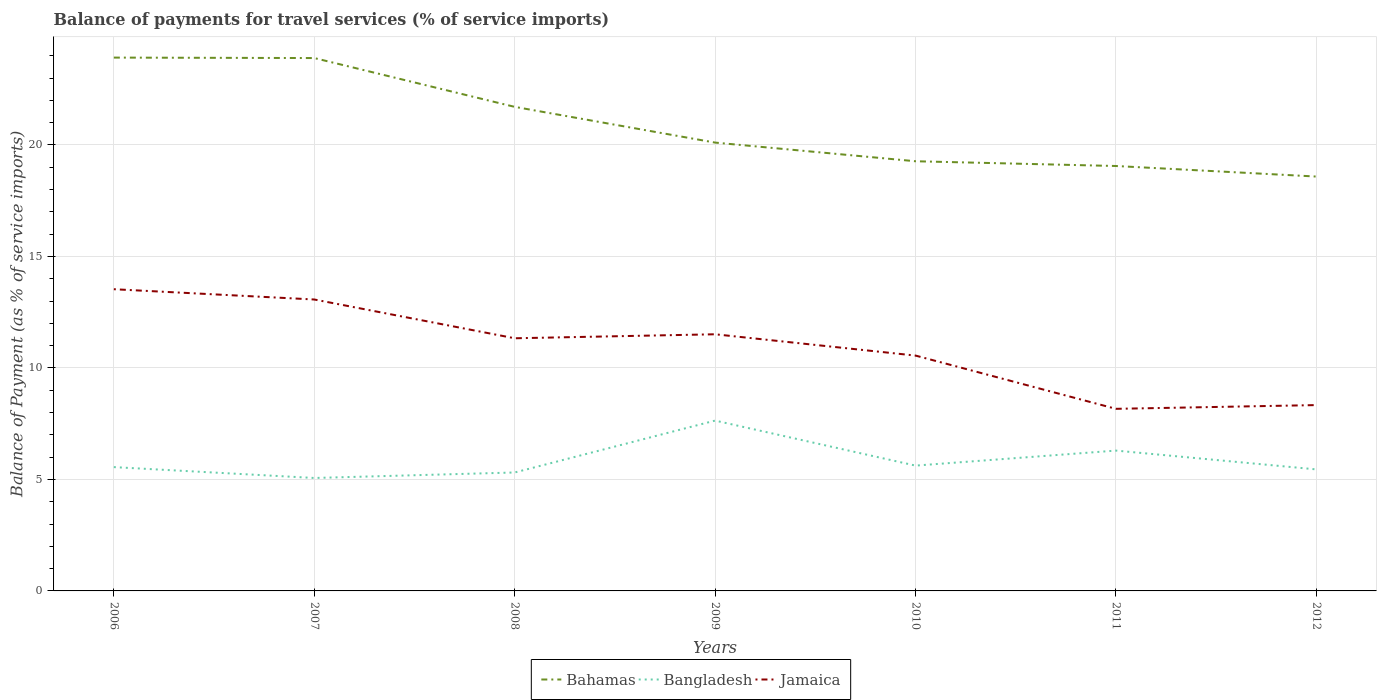Does the line corresponding to Bahamas intersect with the line corresponding to Jamaica?
Your answer should be very brief. No. Is the number of lines equal to the number of legend labels?
Provide a short and direct response. Yes. Across all years, what is the maximum balance of payments for travel services in Bahamas?
Provide a succinct answer. 18.58. In which year was the balance of payments for travel services in Jamaica maximum?
Offer a very short reply. 2011. What is the total balance of payments for travel services in Jamaica in the graph?
Your response must be concise. 0.78. What is the difference between the highest and the second highest balance of payments for travel services in Jamaica?
Make the answer very short. 5.36. What is the difference between the highest and the lowest balance of payments for travel services in Bangladesh?
Your response must be concise. 2. Is the balance of payments for travel services in Bangladesh strictly greater than the balance of payments for travel services in Bahamas over the years?
Your answer should be compact. Yes. What is the difference between two consecutive major ticks on the Y-axis?
Offer a very short reply. 5. Are the values on the major ticks of Y-axis written in scientific E-notation?
Make the answer very short. No. Where does the legend appear in the graph?
Your answer should be compact. Bottom center. How are the legend labels stacked?
Provide a short and direct response. Horizontal. What is the title of the graph?
Give a very brief answer. Balance of payments for travel services (% of service imports). What is the label or title of the Y-axis?
Keep it short and to the point. Balance of Payment (as % of service imports). What is the Balance of Payment (as % of service imports) in Bahamas in 2006?
Ensure brevity in your answer.  23.92. What is the Balance of Payment (as % of service imports) of Bangladesh in 2006?
Provide a short and direct response. 5.55. What is the Balance of Payment (as % of service imports) of Jamaica in 2006?
Give a very brief answer. 13.53. What is the Balance of Payment (as % of service imports) in Bahamas in 2007?
Make the answer very short. 23.89. What is the Balance of Payment (as % of service imports) in Bangladesh in 2007?
Keep it short and to the point. 5.06. What is the Balance of Payment (as % of service imports) in Jamaica in 2007?
Your answer should be compact. 13.07. What is the Balance of Payment (as % of service imports) of Bahamas in 2008?
Ensure brevity in your answer.  21.71. What is the Balance of Payment (as % of service imports) of Bangladesh in 2008?
Your response must be concise. 5.31. What is the Balance of Payment (as % of service imports) of Jamaica in 2008?
Make the answer very short. 11.33. What is the Balance of Payment (as % of service imports) in Bahamas in 2009?
Ensure brevity in your answer.  20.1. What is the Balance of Payment (as % of service imports) in Bangladesh in 2009?
Provide a succinct answer. 7.64. What is the Balance of Payment (as % of service imports) of Jamaica in 2009?
Keep it short and to the point. 11.51. What is the Balance of Payment (as % of service imports) of Bahamas in 2010?
Offer a very short reply. 19.27. What is the Balance of Payment (as % of service imports) of Bangladesh in 2010?
Provide a succinct answer. 5.62. What is the Balance of Payment (as % of service imports) in Jamaica in 2010?
Make the answer very short. 10.55. What is the Balance of Payment (as % of service imports) of Bahamas in 2011?
Give a very brief answer. 19.05. What is the Balance of Payment (as % of service imports) in Bangladesh in 2011?
Your answer should be compact. 6.29. What is the Balance of Payment (as % of service imports) of Jamaica in 2011?
Provide a succinct answer. 8.17. What is the Balance of Payment (as % of service imports) in Bahamas in 2012?
Provide a succinct answer. 18.58. What is the Balance of Payment (as % of service imports) of Bangladesh in 2012?
Provide a succinct answer. 5.45. What is the Balance of Payment (as % of service imports) of Jamaica in 2012?
Offer a very short reply. 8.33. Across all years, what is the maximum Balance of Payment (as % of service imports) in Bahamas?
Ensure brevity in your answer.  23.92. Across all years, what is the maximum Balance of Payment (as % of service imports) of Bangladesh?
Give a very brief answer. 7.64. Across all years, what is the maximum Balance of Payment (as % of service imports) in Jamaica?
Ensure brevity in your answer.  13.53. Across all years, what is the minimum Balance of Payment (as % of service imports) of Bahamas?
Your answer should be very brief. 18.58. Across all years, what is the minimum Balance of Payment (as % of service imports) of Bangladesh?
Keep it short and to the point. 5.06. Across all years, what is the minimum Balance of Payment (as % of service imports) in Jamaica?
Ensure brevity in your answer.  8.17. What is the total Balance of Payment (as % of service imports) of Bahamas in the graph?
Your answer should be compact. 146.52. What is the total Balance of Payment (as % of service imports) of Bangladesh in the graph?
Provide a succinct answer. 40.93. What is the total Balance of Payment (as % of service imports) in Jamaica in the graph?
Offer a terse response. 76.49. What is the difference between the Balance of Payment (as % of service imports) of Bahamas in 2006 and that in 2007?
Offer a very short reply. 0.02. What is the difference between the Balance of Payment (as % of service imports) in Bangladesh in 2006 and that in 2007?
Keep it short and to the point. 0.49. What is the difference between the Balance of Payment (as % of service imports) of Jamaica in 2006 and that in 2007?
Your answer should be compact. 0.46. What is the difference between the Balance of Payment (as % of service imports) of Bahamas in 2006 and that in 2008?
Your response must be concise. 2.21. What is the difference between the Balance of Payment (as % of service imports) in Bangladesh in 2006 and that in 2008?
Your response must be concise. 0.24. What is the difference between the Balance of Payment (as % of service imports) in Jamaica in 2006 and that in 2008?
Make the answer very short. 2.2. What is the difference between the Balance of Payment (as % of service imports) in Bahamas in 2006 and that in 2009?
Your answer should be very brief. 3.81. What is the difference between the Balance of Payment (as % of service imports) of Bangladesh in 2006 and that in 2009?
Your response must be concise. -2.09. What is the difference between the Balance of Payment (as % of service imports) of Jamaica in 2006 and that in 2009?
Offer a very short reply. 2.02. What is the difference between the Balance of Payment (as % of service imports) in Bahamas in 2006 and that in 2010?
Offer a very short reply. 4.65. What is the difference between the Balance of Payment (as % of service imports) of Bangladesh in 2006 and that in 2010?
Your answer should be compact. -0.07. What is the difference between the Balance of Payment (as % of service imports) of Jamaica in 2006 and that in 2010?
Ensure brevity in your answer.  2.98. What is the difference between the Balance of Payment (as % of service imports) in Bahamas in 2006 and that in 2011?
Provide a succinct answer. 4.86. What is the difference between the Balance of Payment (as % of service imports) of Bangladesh in 2006 and that in 2011?
Provide a succinct answer. -0.74. What is the difference between the Balance of Payment (as % of service imports) in Jamaica in 2006 and that in 2011?
Your response must be concise. 5.36. What is the difference between the Balance of Payment (as % of service imports) in Bahamas in 2006 and that in 2012?
Your answer should be compact. 5.33. What is the difference between the Balance of Payment (as % of service imports) of Bangladesh in 2006 and that in 2012?
Keep it short and to the point. 0.1. What is the difference between the Balance of Payment (as % of service imports) in Jamaica in 2006 and that in 2012?
Offer a very short reply. 5.2. What is the difference between the Balance of Payment (as % of service imports) in Bahamas in 2007 and that in 2008?
Give a very brief answer. 2.19. What is the difference between the Balance of Payment (as % of service imports) in Bangladesh in 2007 and that in 2008?
Give a very brief answer. -0.25. What is the difference between the Balance of Payment (as % of service imports) of Jamaica in 2007 and that in 2008?
Keep it short and to the point. 1.74. What is the difference between the Balance of Payment (as % of service imports) in Bahamas in 2007 and that in 2009?
Offer a terse response. 3.79. What is the difference between the Balance of Payment (as % of service imports) in Bangladesh in 2007 and that in 2009?
Offer a terse response. -2.57. What is the difference between the Balance of Payment (as % of service imports) of Jamaica in 2007 and that in 2009?
Give a very brief answer. 1.56. What is the difference between the Balance of Payment (as % of service imports) of Bahamas in 2007 and that in 2010?
Keep it short and to the point. 4.63. What is the difference between the Balance of Payment (as % of service imports) in Bangladesh in 2007 and that in 2010?
Ensure brevity in your answer.  -0.55. What is the difference between the Balance of Payment (as % of service imports) of Jamaica in 2007 and that in 2010?
Offer a terse response. 2.51. What is the difference between the Balance of Payment (as % of service imports) in Bahamas in 2007 and that in 2011?
Provide a short and direct response. 4.84. What is the difference between the Balance of Payment (as % of service imports) in Bangladesh in 2007 and that in 2011?
Keep it short and to the point. -1.23. What is the difference between the Balance of Payment (as % of service imports) in Jamaica in 2007 and that in 2011?
Make the answer very short. 4.9. What is the difference between the Balance of Payment (as % of service imports) in Bahamas in 2007 and that in 2012?
Ensure brevity in your answer.  5.31. What is the difference between the Balance of Payment (as % of service imports) in Bangladesh in 2007 and that in 2012?
Offer a terse response. -0.38. What is the difference between the Balance of Payment (as % of service imports) in Jamaica in 2007 and that in 2012?
Your answer should be very brief. 4.73. What is the difference between the Balance of Payment (as % of service imports) in Bahamas in 2008 and that in 2009?
Give a very brief answer. 1.6. What is the difference between the Balance of Payment (as % of service imports) of Bangladesh in 2008 and that in 2009?
Make the answer very short. -2.33. What is the difference between the Balance of Payment (as % of service imports) of Jamaica in 2008 and that in 2009?
Provide a succinct answer. -0.18. What is the difference between the Balance of Payment (as % of service imports) of Bahamas in 2008 and that in 2010?
Offer a terse response. 2.44. What is the difference between the Balance of Payment (as % of service imports) of Bangladesh in 2008 and that in 2010?
Your answer should be compact. -0.31. What is the difference between the Balance of Payment (as % of service imports) in Jamaica in 2008 and that in 2010?
Keep it short and to the point. 0.78. What is the difference between the Balance of Payment (as % of service imports) of Bahamas in 2008 and that in 2011?
Your answer should be very brief. 2.65. What is the difference between the Balance of Payment (as % of service imports) of Bangladesh in 2008 and that in 2011?
Offer a very short reply. -0.98. What is the difference between the Balance of Payment (as % of service imports) in Jamaica in 2008 and that in 2011?
Offer a very short reply. 3.16. What is the difference between the Balance of Payment (as % of service imports) in Bahamas in 2008 and that in 2012?
Provide a succinct answer. 3.12. What is the difference between the Balance of Payment (as % of service imports) of Bangladesh in 2008 and that in 2012?
Offer a terse response. -0.14. What is the difference between the Balance of Payment (as % of service imports) in Jamaica in 2008 and that in 2012?
Keep it short and to the point. 3. What is the difference between the Balance of Payment (as % of service imports) of Bahamas in 2009 and that in 2010?
Ensure brevity in your answer.  0.84. What is the difference between the Balance of Payment (as % of service imports) in Bangladesh in 2009 and that in 2010?
Keep it short and to the point. 2.02. What is the difference between the Balance of Payment (as % of service imports) of Jamaica in 2009 and that in 2010?
Provide a short and direct response. 0.96. What is the difference between the Balance of Payment (as % of service imports) in Bahamas in 2009 and that in 2011?
Provide a short and direct response. 1.05. What is the difference between the Balance of Payment (as % of service imports) of Bangladesh in 2009 and that in 2011?
Your answer should be very brief. 1.34. What is the difference between the Balance of Payment (as % of service imports) in Jamaica in 2009 and that in 2011?
Make the answer very short. 3.34. What is the difference between the Balance of Payment (as % of service imports) of Bahamas in 2009 and that in 2012?
Your answer should be very brief. 1.52. What is the difference between the Balance of Payment (as % of service imports) in Bangladesh in 2009 and that in 2012?
Make the answer very short. 2.19. What is the difference between the Balance of Payment (as % of service imports) in Jamaica in 2009 and that in 2012?
Ensure brevity in your answer.  3.18. What is the difference between the Balance of Payment (as % of service imports) of Bahamas in 2010 and that in 2011?
Offer a terse response. 0.21. What is the difference between the Balance of Payment (as % of service imports) of Bangladesh in 2010 and that in 2011?
Give a very brief answer. -0.67. What is the difference between the Balance of Payment (as % of service imports) in Jamaica in 2010 and that in 2011?
Provide a short and direct response. 2.39. What is the difference between the Balance of Payment (as % of service imports) in Bahamas in 2010 and that in 2012?
Give a very brief answer. 0.69. What is the difference between the Balance of Payment (as % of service imports) in Bangladesh in 2010 and that in 2012?
Your answer should be very brief. 0.17. What is the difference between the Balance of Payment (as % of service imports) in Jamaica in 2010 and that in 2012?
Offer a terse response. 2.22. What is the difference between the Balance of Payment (as % of service imports) in Bahamas in 2011 and that in 2012?
Give a very brief answer. 0.47. What is the difference between the Balance of Payment (as % of service imports) in Bangladesh in 2011 and that in 2012?
Your response must be concise. 0.84. What is the difference between the Balance of Payment (as % of service imports) in Jamaica in 2011 and that in 2012?
Your answer should be very brief. -0.17. What is the difference between the Balance of Payment (as % of service imports) in Bahamas in 2006 and the Balance of Payment (as % of service imports) in Bangladesh in 2007?
Your answer should be very brief. 18.85. What is the difference between the Balance of Payment (as % of service imports) in Bahamas in 2006 and the Balance of Payment (as % of service imports) in Jamaica in 2007?
Your answer should be compact. 10.85. What is the difference between the Balance of Payment (as % of service imports) of Bangladesh in 2006 and the Balance of Payment (as % of service imports) of Jamaica in 2007?
Ensure brevity in your answer.  -7.52. What is the difference between the Balance of Payment (as % of service imports) in Bahamas in 2006 and the Balance of Payment (as % of service imports) in Bangladesh in 2008?
Your response must be concise. 18.6. What is the difference between the Balance of Payment (as % of service imports) in Bahamas in 2006 and the Balance of Payment (as % of service imports) in Jamaica in 2008?
Your answer should be very brief. 12.59. What is the difference between the Balance of Payment (as % of service imports) in Bangladesh in 2006 and the Balance of Payment (as % of service imports) in Jamaica in 2008?
Provide a short and direct response. -5.78. What is the difference between the Balance of Payment (as % of service imports) of Bahamas in 2006 and the Balance of Payment (as % of service imports) of Bangladesh in 2009?
Your answer should be very brief. 16.28. What is the difference between the Balance of Payment (as % of service imports) of Bahamas in 2006 and the Balance of Payment (as % of service imports) of Jamaica in 2009?
Your answer should be very brief. 12.41. What is the difference between the Balance of Payment (as % of service imports) of Bangladesh in 2006 and the Balance of Payment (as % of service imports) of Jamaica in 2009?
Provide a short and direct response. -5.96. What is the difference between the Balance of Payment (as % of service imports) in Bahamas in 2006 and the Balance of Payment (as % of service imports) in Bangladesh in 2010?
Provide a short and direct response. 18.3. What is the difference between the Balance of Payment (as % of service imports) of Bahamas in 2006 and the Balance of Payment (as % of service imports) of Jamaica in 2010?
Provide a succinct answer. 13.36. What is the difference between the Balance of Payment (as % of service imports) of Bangladesh in 2006 and the Balance of Payment (as % of service imports) of Jamaica in 2010?
Ensure brevity in your answer.  -5. What is the difference between the Balance of Payment (as % of service imports) of Bahamas in 2006 and the Balance of Payment (as % of service imports) of Bangladesh in 2011?
Provide a succinct answer. 17.62. What is the difference between the Balance of Payment (as % of service imports) in Bahamas in 2006 and the Balance of Payment (as % of service imports) in Jamaica in 2011?
Your answer should be very brief. 15.75. What is the difference between the Balance of Payment (as % of service imports) of Bangladesh in 2006 and the Balance of Payment (as % of service imports) of Jamaica in 2011?
Make the answer very short. -2.61. What is the difference between the Balance of Payment (as % of service imports) in Bahamas in 2006 and the Balance of Payment (as % of service imports) in Bangladesh in 2012?
Give a very brief answer. 18.47. What is the difference between the Balance of Payment (as % of service imports) of Bahamas in 2006 and the Balance of Payment (as % of service imports) of Jamaica in 2012?
Your answer should be compact. 15.58. What is the difference between the Balance of Payment (as % of service imports) of Bangladesh in 2006 and the Balance of Payment (as % of service imports) of Jamaica in 2012?
Give a very brief answer. -2.78. What is the difference between the Balance of Payment (as % of service imports) in Bahamas in 2007 and the Balance of Payment (as % of service imports) in Bangladesh in 2008?
Offer a very short reply. 18.58. What is the difference between the Balance of Payment (as % of service imports) of Bahamas in 2007 and the Balance of Payment (as % of service imports) of Jamaica in 2008?
Offer a very short reply. 12.57. What is the difference between the Balance of Payment (as % of service imports) in Bangladesh in 2007 and the Balance of Payment (as % of service imports) in Jamaica in 2008?
Make the answer very short. -6.26. What is the difference between the Balance of Payment (as % of service imports) in Bahamas in 2007 and the Balance of Payment (as % of service imports) in Bangladesh in 2009?
Provide a succinct answer. 16.26. What is the difference between the Balance of Payment (as % of service imports) in Bahamas in 2007 and the Balance of Payment (as % of service imports) in Jamaica in 2009?
Give a very brief answer. 12.39. What is the difference between the Balance of Payment (as % of service imports) of Bangladesh in 2007 and the Balance of Payment (as % of service imports) of Jamaica in 2009?
Your answer should be compact. -6.44. What is the difference between the Balance of Payment (as % of service imports) in Bahamas in 2007 and the Balance of Payment (as % of service imports) in Bangladesh in 2010?
Keep it short and to the point. 18.28. What is the difference between the Balance of Payment (as % of service imports) in Bahamas in 2007 and the Balance of Payment (as % of service imports) in Jamaica in 2010?
Offer a terse response. 13.34. What is the difference between the Balance of Payment (as % of service imports) in Bangladesh in 2007 and the Balance of Payment (as % of service imports) in Jamaica in 2010?
Make the answer very short. -5.49. What is the difference between the Balance of Payment (as % of service imports) of Bahamas in 2007 and the Balance of Payment (as % of service imports) of Bangladesh in 2011?
Provide a short and direct response. 17.6. What is the difference between the Balance of Payment (as % of service imports) of Bahamas in 2007 and the Balance of Payment (as % of service imports) of Jamaica in 2011?
Make the answer very short. 15.73. What is the difference between the Balance of Payment (as % of service imports) in Bangladesh in 2007 and the Balance of Payment (as % of service imports) in Jamaica in 2011?
Ensure brevity in your answer.  -3.1. What is the difference between the Balance of Payment (as % of service imports) in Bahamas in 2007 and the Balance of Payment (as % of service imports) in Bangladesh in 2012?
Offer a terse response. 18.45. What is the difference between the Balance of Payment (as % of service imports) in Bahamas in 2007 and the Balance of Payment (as % of service imports) in Jamaica in 2012?
Offer a terse response. 15.56. What is the difference between the Balance of Payment (as % of service imports) of Bangladesh in 2007 and the Balance of Payment (as % of service imports) of Jamaica in 2012?
Keep it short and to the point. -3.27. What is the difference between the Balance of Payment (as % of service imports) of Bahamas in 2008 and the Balance of Payment (as % of service imports) of Bangladesh in 2009?
Give a very brief answer. 14.07. What is the difference between the Balance of Payment (as % of service imports) of Bahamas in 2008 and the Balance of Payment (as % of service imports) of Jamaica in 2009?
Keep it short and to the point. 10.2. What is the difference between the Balance of Payment (as % of service imports) in Bangladesh in 2008 and the Balance of Payment (as % of service imports) in Jamaica in 2009?
Offer a very short reply. -6.2. What is the difference between the Balance of Payment (as % of service imports) of Bahamas in 2008 and the Balance of Payment (as % of service imports) of Bangladesh in 2010?
Give a very brief answer. 16.09. What is the difference between the Balance of Payment (as % of service imports) of Bahamas in 2008 and the Balance of Payment (as % of service imports) of Jamaica in 2010?
Offer a terse response. 11.15. What is the difference between the Balance of Payment (as % of service imports) of Bangladesh in 2008 and the Balance of Payment (as % of service imports) of Jamaica in 2010?
Offer a very short reply. -5.24. What is the difference between the Balance of Payment (as % of service imports) of Bahamas in 2008 and the Balance of Payment (as % of service imports) of Bangladesh in 2011?
Your answer should be compact. 15.41. What is the difference between the Balance of Payment (as % of service imports) of Bahamas in 2008 and the Balance of Payment (as % of service imports) of Jamaica in 2011?
Offer a very short reply. 13.54. What is the difference between the Balance of Payment (as % of service imports) of Bangladesh in 2008 and the Balance of Payment (as % of service imports) of Jamaica in 2011?
Offer a very short reply. -2.85. What is the difference between the Balance of Payment (as % of service imports) of Bahamas in 2008 and the Balance of Payment (as % of service imports) of Bangladesh in 2012?
Your answer should be compact. 16.26. What is the difference between the Balance of Payment (as % of service imports) of Bahamas in 2008 and the Balance of Payment (as % of service imports) of Jamaica in 2012?
Offer a very short reply. 13.37. What is the difference between the Balance of Payment (as % of service imports) of Bangladesh in 2008 and the Balance of Payment (as % of service imports) of Jamaica in 2012?
Provide a short and direct response. -3.02. What is the difference between the Balance of Payment (as % of service imports) in Bahamas in 2009 and the Balance of Payment (as % of service imports) in Bangladesh in 2010?
Your answer should be very brief. 14.48. What is the difference between the Balance of Payment (as % of service imports) of Bahamas in 2009 and the Balance of Payment (as % of service imports) of Jamaica in 2010?
Give a very brief answer. 9.55. What is the difference between the Balance of Payment (as % of service imports) of Bangladesh in 2009 and the Balance of Payment (as % of service imports) of Jamaica in 2010?
Make the answer very short. -2.92. What is the difference between the Balance of Payment (as % of service imports) in Bahamas in 2009 and the Balance of Payment (as % of service imports) in Bangladesh in 2011?
Give a very brief answer. 13.81. What is the difference between the Balance of Payment (as % of service imports) in Bahamas in 2009 and the Balance of Payment (as % of service imports) in Jamaica in 2011?
Offer a terse response. 11.94. What is the difference between the Balance of Payment (as % of service imports) of Bangladesh in 2009 and the Balance of Payment (as % of service imports) of Jamaica in 2011?
Your answer should be very brief. -0.53. What is the difference between the Balance of Payment (as % of service imports) in Bahamas in 2009 and the Balance of Payment (as % of service imports) in Bangladesh in 2012?
Ensure brevity in your answer.  14.65. What is the difference between the Balance of Payment (as % of service imports) of Bahamas in 2009 and the Balance of Payment (as % of service imports) of Jamaica in 2012?
Offer a very short reply. 11.77. What is the difference between the Balance of Payment (as % of service imports) in Bangladesh in 2009 and the Balance of Payment (as % of service imports) in Jamaica in 2012?
Provide a short and direct response. -0.7. What is the difference between the Balance of Payment (as % of service imports) of Bahamas in 2010 and the Balance of Payment (as % of service imports) of Bangladesh in 2011?
Give a very brief answer. 12.97. What is the difference between the Balance of Payment (as % of service imports) of Bahamas in 2010 and the Balance of Payment (as % of service imports) of Jamaica in 2011?
Your answer should be compact. 11.1. What is the difference between the Balance of Payment (as % of service imports) in Bangladesh in 2010 and the Balance of Payment (as % of service imports) in Jamaica in 2011?
Ensure brevity in your answer.  -2.55. What is the difference between the Balance of Payment (as % of service imports) in Bahamas in 2010 and the Balance of Payment (as % of service imports) in Bangladesh in 2012?
Your answer should be very brief. 13.82. What is the difference between the Balance of Payment (as % of service imports) in Bahamas in 2010 and the Balance of Payment (as % of service imports) in Jamaica in 2012?
Keep it short and to the point. 10.93. What is the difference between the Balance of Payment (as % of service imports) in Bangladesh in 2010 and the Balance of Payment (as % of service imports) in Jamaica in 2012?
Your answer should be very brief. -2.71. What is the difference between the Balance of Payment (as % of service imports) in Bahamas in 2011 and the Balance of Payment (as % of service imports) in Bangladesh in 2012?
Offer a terse response. 13.6. What is the difference between the Balance of Payment (as % of service imports) of Bahamas in 2011 and the Balance of Payment (as % of service imports) of Jamaica in 2012?
Give a very brief answer. 10.72. What is the difference between the Balance of Payment (as % of service imports) of Bangladesh in 2011 and the Balance of Payment (as % of service imports) of Jamaica in 2012?
Ensure brevity in your answer.  -2.04. What is the average Balance of Payment (as % of service imports) of Bahamas per year?
Ensure brevity in your answer.  20.93. What is the average Balance of Payment (as % of service imports) in Bangladesh per year?
Provide a succinct answer. 5.85. What is the average Balance of Payment (as % of service imports) of Jamaica per year?
Your answer should be compact. 10.93. In the year 2006, what is the difference between the Balance of Payment (as % of service imports) in Bahamas and Balance of Payment (as % of service imports) in Bangladesh?
Provide a succinct answer. 18.36. In the year 2006, what is the difference between the Balance of Payment (as % of service imports) in Bahamas and Balance of Payment (as % of service imports) in Jamaica?
Your answer should be compact. 10.39. In the year 2006, what is the difference between the Balance of Payment (as % of service imports) in Bangladesh and Balance of Payment (as % of service imports) in Jamaica?
Your response must be concise. -7.98. In the year 2007, what is the difference between the Balance of Payment (as % of service imports) of Bahamas and Balance of Payment (as % of service imports) of Bangladesh?
Keep it short and to the point. 18.83. In the year 2007, what is the difference between the Balance of Payment (as % of service imports) of Bahamas and Balance of Payment (as % of service imports) of Jamaica?
Give a very brief answer. 10.83. In the year 2007, what is the difference between the Balance of Payment (as % of service imports) in Bangladesh and Balance of Payment (as % of service imports) in Jamaica?
Your response must be concise. -8. In the year 2008, what is the difference between the Balance of Payment (as % of service imports) of Bahamas and Balance of Payment (as % of service imports) of Bangladesh?
Ensure brevity in your answer.  16.39. In the year 2008, what is the difference between the Balance of Payment (as % of service imports) of Bahamas and Balance of Payment (as % of service imports) of Jamaica?
Provide a short and direct response. 10.38. In the year 2008, what is the difference between the Balance of Payment (as % of service imports) in Bangladesh and Balance of Payment (as % of service imports) in Jamaica?
Provide a succinct answer. -6.02. In the year 2009, what is the difference between the Balance of Payment (as % of service imports) of Bahamas and Balance of Payment (as % of service imports) of Bangladesh?
Keep it short and to the point. 12.47. In the year 2009, what is the difference between the Balance of Payment (as % of service imports) of Bahamas and Balance of Payment (as % of service imports) of Jamaica?
Your answer should be very brief. 8.6. In the year 2009, what is the difference between the Balance of Payment (as % of service imports) in Bangladesh and Balance of Payment (as % of service imports) in Jamaica?
Your response must be concise. -3.87. In the year 2010, what is the difference between the Balance of Payment (as % of service imports) in Bahamas and Balance of Payment (as % of service imports) in Bangladesh?
Your response must be concise. 13.65. In the year 2010, what is the difference between the Balance of Payment (as % of service imports) in Bahamas and Balance of Payment (as % of service imports) in Jamaica?
Provide a succinct answer. 8.71. In the year 2010, what is the difference between the Balance of Payment (as % of service imports) in Bangladesh and Balance of Payment (as % of service imports) in Jamaica?
Ensure brevity in your answer.  -4.93. In the year 2011, what is the difference between the Balance of Payment (as % of service imports) of Bahamas and Balance of Payment (as % of service imports) of Bangladesh?
Your response must be concise. 12.76. In the year 2011, what is the difference between the Balance of Payment (as % of service imports) of Bahamas and Balance of Payment (as % of service imports) of Jamaica?
Offer a very short reply. 10.89. In the year 2011, what is the difference between the Balance of Payment (as % of service imports) in Bangladesh and Balance of Payment (as % of service imports) in Jamaica?
Make the answer very short. -1.87. In the year 2012, what is the difference between the Balance of Payment (as % of service imports) in Bahamas and Balance of Payment (as % of service imports) in Bangladesh?
Ensure brevity in your answer.  13.13. In the year 2012, what is the difference between the Balance of Payment (as % of service imports) in Bahamas and Balance of Payment (as % of service imports) in Jamaica?
Provide a short and direct response. 10.25. In the year 2012, what is the difference between the Balance of Payment (as % of service imports) of Bangladesh and Balance of Payment (as % of service imports) of Jamaica?
Your answer should be compact. -2.88. What is the ratio of the Balance of Payment (as % of service imports) of Bangladesh in 2006 to that in 2007?
Offer a terse response. 1.1. What is the ratio of the Balance of Payment (as % of service imports) of Jamaica in 2006 to that in 2007?
Provide a succinct answer. 1.04. What is the ratio of the Balance of Payment (as % of service imports) of Bahamas in 2006 to that in 2008?
Make the answer very short. 1.1. What is the ratio of the Balance of Payment (as % of service imports) in Bangladesh in 2006 to that in 2008?
Keep it short and to the point. 1.05. What is the ratio of the Balance of Payment (as % of service imports) in Jamaica in 2006 to that in 2008?
Offer a terse response. 1.19. What is the ratio of the Balance of Payment (as % of service imports) of Bahamas in 2006 to that in 2009?
Keep it short and to the point. 1.19. What is the ratio of the Balance of Payment (as % of service imports) in Bangladesh in 2006 to that in 2009?
Offer a very short reply. 0.73. What is the ratio of the Balance of Payment (as % of service imports) of Jamaica in 2006 to that in 2009?
Offer a very short reply. 1.18. What is the ratio of the Balance of Payment (as % of service imports) of Bahamas in 2006 to that in 2010?
Your response must be concise. 1.24. What is the ratio of the Balance of Payment (as % of service imports) in Jamaica in 2006 to that in 2010?
Provide a succinct answer. 1.28. What is the ratio of the Balance of Payment (as % of service imports) of Bahamas in 2006 to that in 2011?
Make the answer very short. 1.26. What is the ratio of the Balance of Payment (as % of service imports) of Bangladesh in 2006 to that in 2011?
Keep it short and to the point. 0.88. What is the ratio of the Balance of Payment (as % of service imports) of Jamaica in 2006 to that in 2011?
Offer a terse response. 1.66. What is the ratio of the Balance of Payment (as % of service imports) in Bahamas in 2006 to that in 2012?
Your response must be concise. 1.29. What is the ratio of the Balance of Payment (as % of service imports) in Bangladesh in 2006 to that in 2012?
Your answer should be compact. 1.02. What is the ratio of the Balance of Payment (as % of service imports) in Jamaica in 2006 to that in 2012?
Your response must be concise. 1.62. What is the ratio of the Balance of Payment (as % of service imports) of Bahamas in 2007 to that in 2008?
Give a very brief answer. 1.1. What is the ratio of the Balance of Payment (as % of service imports) of Bangladesh in 2007 to that in 2008?
Ensure brevity in your answer.  0.95. What is the ratio of the Balance of Payment (as % of service imports) in Jamaica in 2007 to that in 2008?
Give a very brief answer. 1.15. What is the ratio of the Balance of Payment (as % of service imports) of Bahamas in 2007 to that in 2009?
Keep it short and to the point. 1.19. What is the ratio of the Balance of Payment (as % of service imports) of Bangladesh in 2007 to that in 2009?
Your answer should be very brief. 0.66. What is the ratio of the Balance of Payment (as % of service imports) of Jamaica in 2007 to that in 2009?
Your response must be concise. 1.14. What is the ratio of the Balance of Payment (as % of service imports) of Bahamas in 2007 to that in 2010?
Offer a very short reply. 1.24. What is the ratio of the Balance of Payment (as % of service imports) in Bangladesh in 2007 to that in 2010?
Provide a short and direct response. 0.9. What is the ratio of the Balance of Payment (as % of service imports) in Jamaica in 2007 to that in 2010?
Your response must be concise. 1.24. What is the ratio of the Balance of Payment (as % of service imports) of Bahamas in 2007 to that in 2011?
Ensure brevity in your answer.  1.25. What is the ratio of the Balance of Payment (as % of service imports) in Bangladesh in 2007 to that in 2011?
Offer a very short reply. 0.8. What is the ratio of the Balance of Payment (as % of service imports) of Jamaica in 2007 to that in 2011?
Your answer should be very brief. 1.6. What is the ratio of the Balance of Payment (as % of service imports) of Bahamas in 2007 to that in 2012?
Your answer should be very brief. 1.29. What is the ratio of the Balance of Payment (as % of service imports) of Bangladesh in 2007 to that in 2012?
Offer a terse response. 0.93. What is the ratio of the Balance of Payment (as % of service imports) in Jamaica in 2007 to that in 2012?
Keep it short and to the point. 1.57. What is the ratio of the Balance of Payment (as % of service imports) of Bahamas in 2008 to that in 2009?
Ensure brevity in your answer.  1.08. What is the ratio of the Balance of Payment (as % of service imports) in Bangladesh in 2008 to that in 2009?
Your response must be concise. 0.7. What is the ratio of the Balance of Payment (as % of service imports) in Jamaica in 2008 to that in 2009?
Ensure brevity in your answer.  0.98. What is the ratio of the Balance of Payment (as % of service imports) of Bahamas in 2008 to that in 2010?
Keep it short and to the point. 1.13. What is the ratio of the Balance of Payment (as % of service imports) in Bangladesh in 2008 to that in 2010?
Offer a terse response. 0.95. What is the ratio of the Balance of Payment (as % of service imports) in Jamaica in 2008 to that in 2010?
Your answer should be compact. 1.07. What is the ratio of the Balance of Payment (as % of service imports) in Bahamas in 2008 to that in 2011?
Provide a short and direct response. 1.14. What is the ratio of the Balance of Payment (as % of service imports) in Bangladesh in 2008 to that in 2011?
Keep it short and to the point. 0.84. What is the ratio of the Balance of Payment (as % of service imports) of Jamaica in 2008 to that in 2011?
Give a very brief answer. 1.39. What is the ratio of the Balance of Payment (as % of service imports) in Bahamas in 2008 to that in 2012?
Provide a short and direct response. 1.17. What is the ratio of the Balance of Payment (as % of service imports) in Bangladesh in 2008 to that in 2012?
Your response must be concise. 0.97. What is the ratio of the Balance of Payment (as % of service imports) of Jamaica in 2008 to that in 2012?
Offer a terse response. 1.36. What is the ratio of the Balance of Payment (as % of service imports) in Bahamas in 2009 to that in 2010?
Give a very brief answer. 1.04. What is the ratio of the Balance of Payment (as % of service imports) in Bangladesh in 2009 to that in 2010?
Keep it short and to the point. 1.36. What is the ratio of the Balance of Payment (as % of service imports) in Jamaica in 2009 to that in 2010?
Keep it short and to the point. 1.09. What is the ratio of the Balance of Payment (as % of service imports) of Bahamas in 2009 to that in 2011?
Make the answer very short. 1.06. What is the ratio of the Balance of Payment (as % of service imports) in Bangladesh in 2009 to that in 2011?
Your answer should be very brief. 1.21. What is the ratio of the Balance of Payment (as % of service imports) of Jamaica in 2009 to that in 2011?
Give a very brief answer. 1.41. What is the ratio of the Balance of Payment (as % of service imports) of Bahamas in 2009 to that in 2012?
Make the answer very short. 1.08. What is the ratio of the Balance of Payment (as % of service imports) in Bangladesh in 2009 to that in 2012?
Your answer should be very brief. 1.4. What is the ratio of the Balance of Payment (as % of service imports) in Jamaica in 2009 to that in 2012?
Give a very brief answer. 1.38. What is the ratio of the Balance of Payment (as % of service imports) in Bahamas in 2010 to that in 2011?
Provide a succinct answer. 1.01. What is the ratio of the Balance of Payment (as % of service imports) of Bangladesh in 2010 to that in 2011?
Your answer should be very brief. 0.89. What is the ratio of the Balance of Payment (as % of service imports) in Jamaica in 2010 to that in 2011?
Your answer should be very brief. 1.29. What is the ratio of the Balance of Payment (as % of service imports) of Bahamas in 2010 to that in 2012?
Ensure brevity in your answer.  1.04. What is the ratio of the Balance of Payment (as % of service imports) in Bangladesh in 2010 to that in 2012?
Your response must be concise. 1.03. What is the ratio of the Balance of Payment (as % of service imports) of Jamaica in 2010 to that in 2012?
Offer a terse response. 1.27. What is the ratio of the Balance of Payment (as % of service imports) in Bahamas in 2011 to that in 2012?
Your answer should be very brief. 1.03. What is the ratio of the Balance of Payment (as % of service imports) in Bangladesh in 2011 to that in 2012?
Ensure brevity in your answer.  1.15. What is the ratio of the Balance of Payment (as % of service imports) in Jamaica in 2011 to that in 2012?
Your answer should be compact. 0.98. What is the difference between the highest and the second highest Balance of Payment (as % of service imports) in Bahamas?
Your answer should be very brief. 0.02. What is the difference between the highest and the second highest Balance of Payment (as % of service imports) in Bangladesh?
Your answer should be compact. 1.34. What is the difference between the highest and the second highest Balance of Payment (as % of service imports) in Jamaica?
Give a very brief answer. 0.46. What is the difference between the highest and the lowest Balance of Payment (as % of service imports) in Bahamas?
Provide a short and direct response. 5.33. What is the difference between the highest and the lowest Balance of Payment (as % of service imports) in Bangladesh?
Your answer should be compact. 2.57. What is the difference between the highest and the lowest Balance of Payment (as % of service imports) in Jamaica?
Your answer should be very brief. 5.36. 